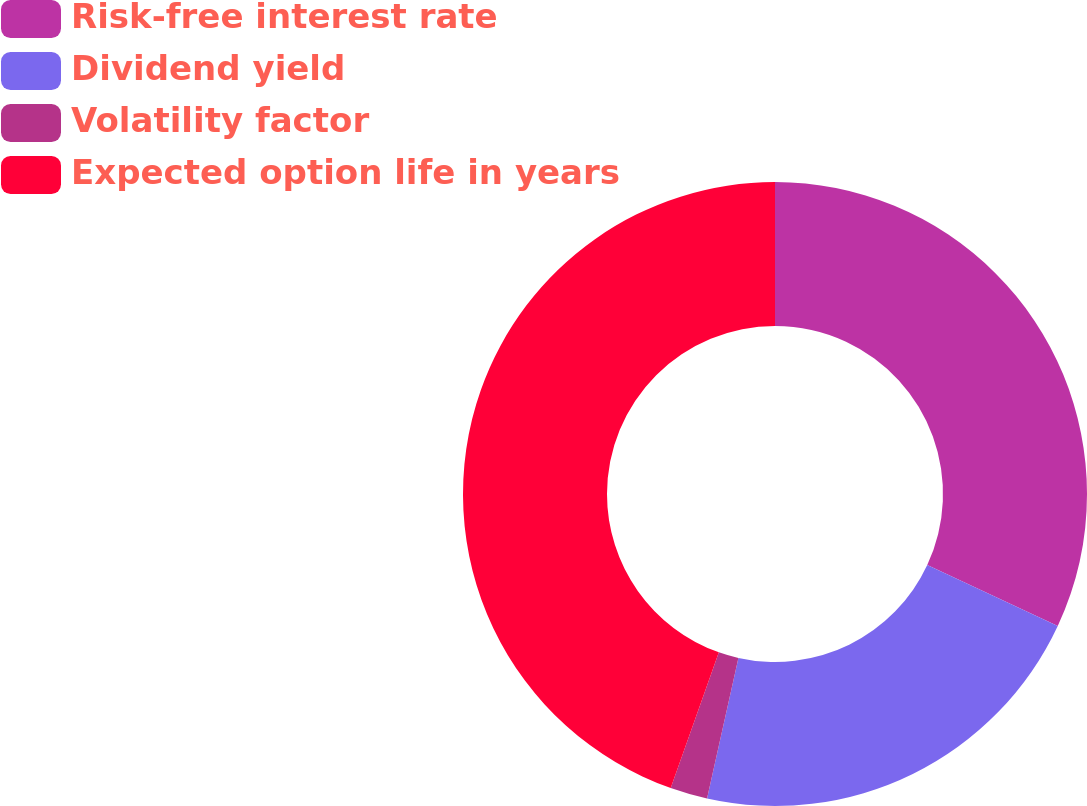<chart> <loc_0><loc_0><loc_500><loc_500><pie_chart><fcel>Risk-free interest rate<fcel>Dividend yield<fcel>Volatility factor<fcel>Expected option life in years<nl><fcel>31.95%<fcel>21.55%<fcel>1.93%<fcel>44.58%<nl></chart> 